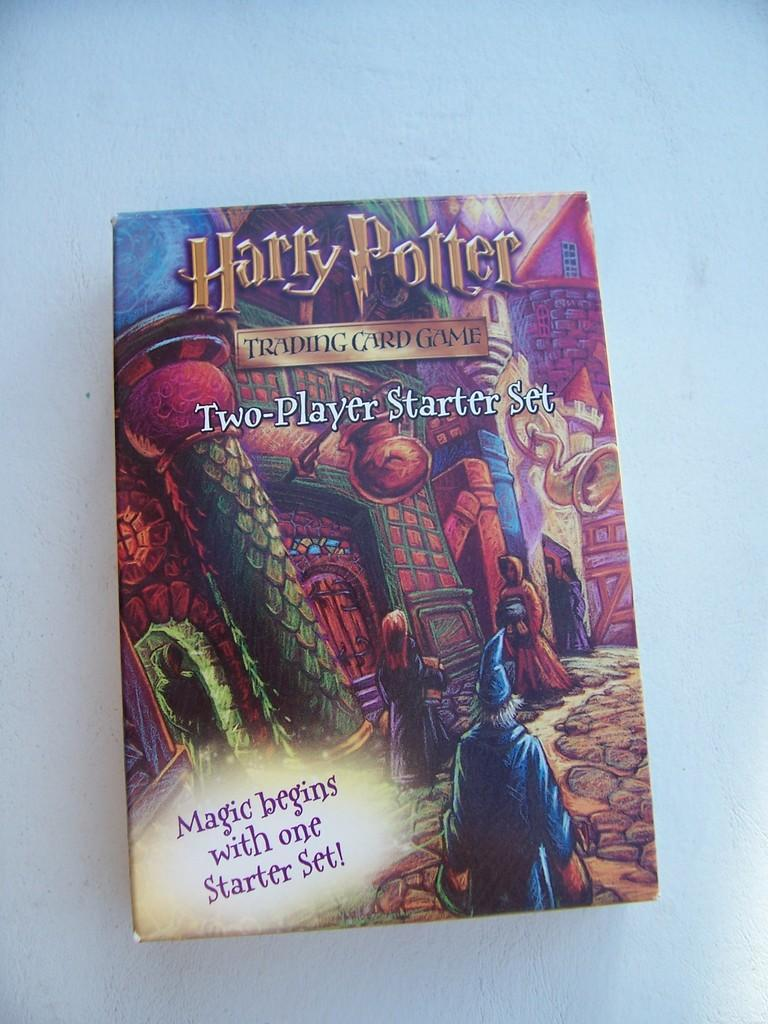What object is located in the center of the image? There is a box in the center of the image. Can you describe the position of the box in the image? The box is placed in the center of the image. What is the box resting on in the image? The box is on a surface in the image. What type of office can be seen in the image? There is no office present in the image; it only features a box placed in the center of the image. 